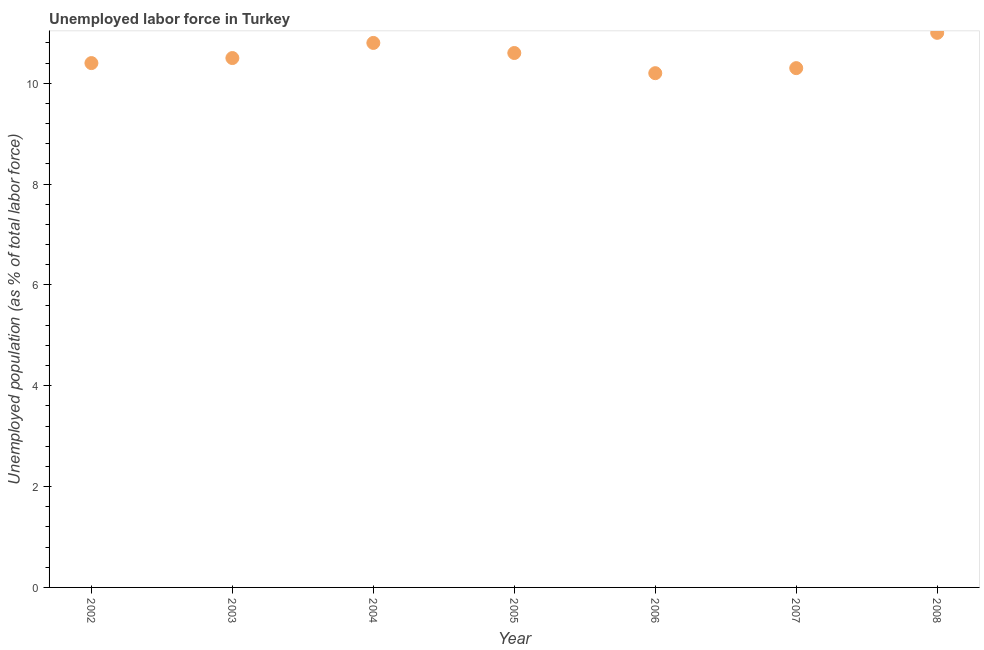What is the total unemployed population in 2003?
Keep it short and to the point. 10.5. Across all years, what is the minimum total unemployed population?
Your response must be concise. 10.2. What is the sum of the total unemployed population?
Provide a short and direct response. 73.8. What is the difference between the total unemployed population in 2004 and 2008?
Your response must be concise. -0.2. What is the average total unemployed population per year?
Provide a succinct answer. 10.54. What is the median total unemployed population?
Your response must be concise. 10.5. In how many years, is the total unemployed population greater than 4.4 %?
Give a very brief answer. 7. What is the ratio of the total unemployed population in 2002 to that in 2005?
Offer a very short reply. 0.98. Is the total unemployed population in 2003 less than that in 2005?
Offer a terse response. Yes. What is the difference between the highest and the second highest total unemployed population?
Give a very brief answer. 0.2. What is the difference between the highest and the lowest total unemployed population?
Provide a short and direct response. 0.8. Are the values on the major ticks of Y-axis written in scientific E-notation?
Your response must be concise. No. Does the graph contain grids?
Provide a succinct answer. No. What is the title of the graph?
Your response must be concise. Unemployed labor force in Turkey. What is the label or title of the Y-axis?
Provide a succinct answer. Unemployed population (as % of total labor force). What is the Unemployed population (as % of total labor force) in 2002?
Offer a very short reply. 10.4. What is the Unemployed population (as % of total labor force) in 2004?
Offer a terse response. 10.8. What is the Unemployed population (as % of total labor force) in 2005?
Offer a terse response. 10.6. What is the Unemployed population (as % of total labor force) in 2006?
Your answer should be very brief. 10.2. What is the Unemployed population (as % of total labor force) in 2007?
Keep it short and to the point. 10.3. What is the difference between the Unemployed population (as % of total labor force) in 2002 and 2004?
Keep it short and to the point. -0.4. What is the difference between the Unemployed population (as % of total labor force) in 2002 and 2007?
Offer a very short reply. 0.1. What is the difference between the Unemployed population (as % of total labor force) in 2003 and 2005?
Your answer should be compact. -0.1. What is the difference between the Unemployed population (as % of total labor force) in 2003 and 2007?
Your answer should be very brief. 0.2. What is the difference between the Unemployed population (as % of total labor force) in 2003 and 2008?
Ensure brevity in your answer.  -0.5. What is the difference between the Unemployed population (as % of total labor force) in 2005 and 2006?
Your response must be concise. 0.4. What is the difference between the Unemployed population (as % of total labor force) in 2005 and 2007?
Ensure brevity in your answer.  0.3. What is the difference between the Unemployed population (as % of total labor force) in 2007 and 2008?
Keep it short and to the point. -0.7. What is the ratio of the Unemployed population (as % of total labor force) in 2002 to that in 2004?
Ensure brevity in your answer.  0.96. What is the ratio of the Unemployed population (as % of total labor force) in 2002 to that in 2007?
Give a very brief answer. 1.01. What is the ratio of the Unemployed population (as % of total labor force) in 2002 to that in 2008?
Give a very brief answer. 0.94. What is the ratio of the Unemployed population (as % of total labor force) in 2003 to that in 2004?
Provide a short and direct response. 0.97. What is the ratio of the Unemployed population (as % of total labor force) in 2003 to that in 2007?
Give a very brief answer. 1.02. What is the ratio of the Unemployed population (as % of total labor force) in 2003 to that in 2008?
Give a very brief answer. 0.95. What is the ratio of the Unemployed population (as % of total labor force) in 2004 to that in 2006?
Provide a succinct answer. 1.06. What is the ratio of the Unemployed population (as % of total labor force) in 2004 to that in 2007?
Offer a terse response. 1.05. What is the ratio of the Unemployed population (as % of total labor force) in 2004 to that in 2008?
Give a very brief answer. 0.98. What is the ratio of the Unemployed population (as % of total labor force) in 2005 to that in 2006?
Ensure brevity in your answer.  1.04. What is the ratio of the Unemployed population (as % of total labor force) in 2006 to that in 2007?
Your answer should be compact. 0.99. What is the ratio of the Unemployed population (as % of total labor force) in 2006 to that in 2008?
Your answer should be compact. 0.93. What is the ratio of the Unemployed population (as % of total labor force) in 2007 to that in 2008?
Your answer should be very brief. 0.94. 